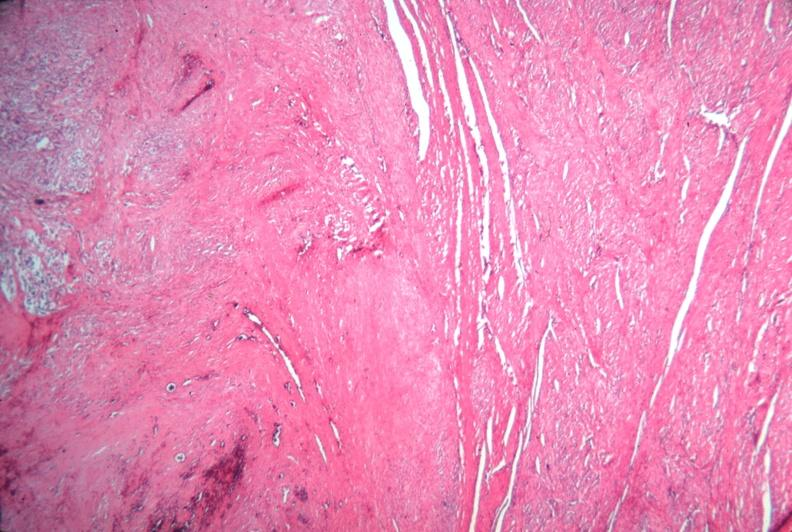does leiomyomas show uterus, leiomyoma?
Answer the question using a single word or phrase. No 